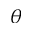Convert formula to latex. <formula><loc_0><loc_0><loc_500><loc_500>\theta</formula> 